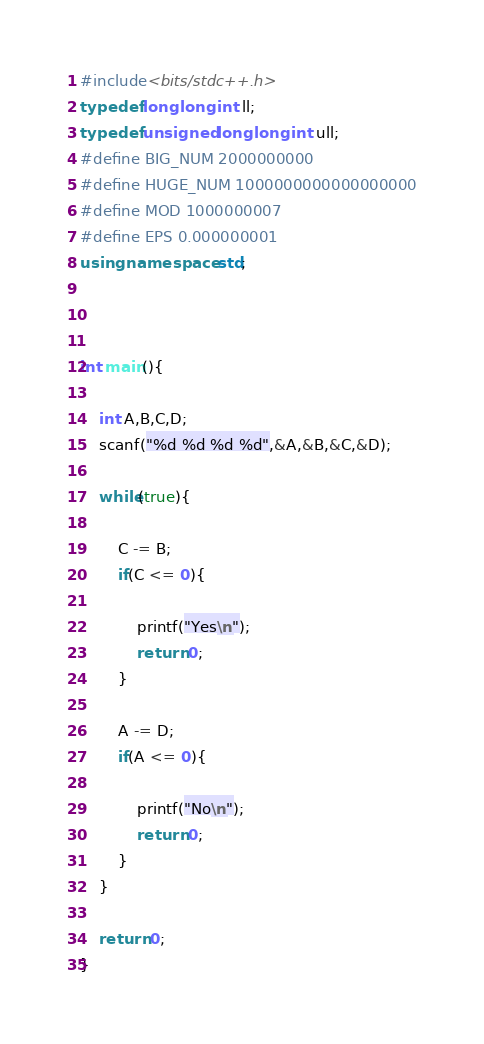Convert code to text. <code><loc_0><loc_0><loc_500><loc_500><_C++_>#include<bits/stdc++.h>
typedef long long int ll;
typedef unsigned long long int ull;
#define BIG_NUM 2000000000
#define HUGE_NUM 1000000000000000000
#define MOD 1000000007
#define EPS 0.000000001
using namespace std;



int main(){

	int A,B,C,D;
	scanf("%d %d %d %d",&A,&B,&C,&D);

	while(true){

		C -= B;
		if(C <= 0){

			printf("Yes\n");
			return 0;
		}

		A -= D;
		if(A <= 0){

			printf("No\n");
			return 0;
		}
	}

	return 0;
}
</code> 